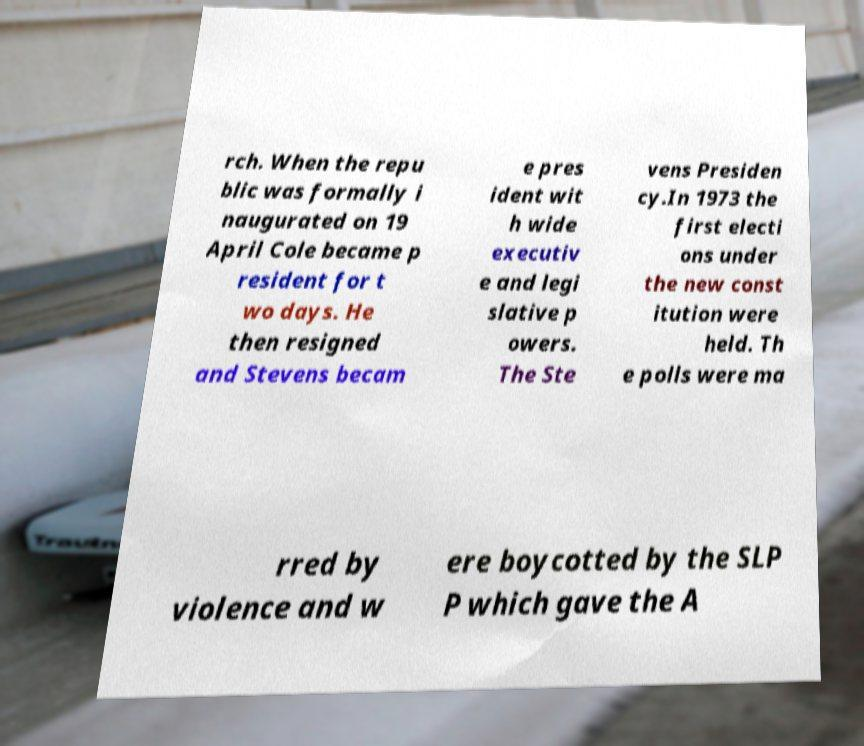Can you accurately transcribe the text from the provided image for me? rch. When the repu blic was formally i naugurated on 19 April Cole became p resident for t wo days. He then resigned and Stevens becam e pres ident wit h wide executiv e and legi slative p owers. The Ste vens Presiden cy.In 1973 the first electi ons under the new const itution were held. Th e polls were ma rred by violence and w ere boycotted by the SLP P which gave the A 